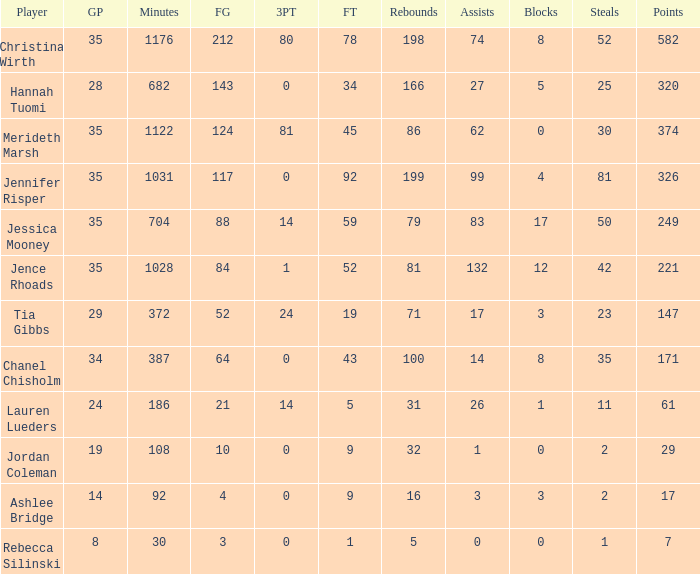What is the lowest number of 3 pointers that occured in games with 52 steals? 80.0. 